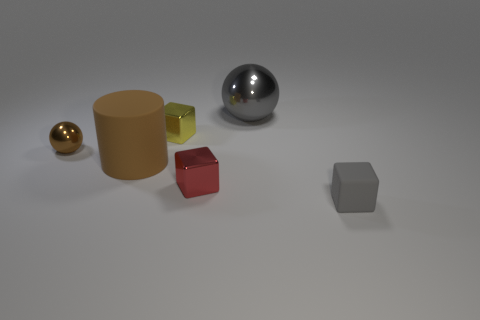Subtract all shiny blocks. How many blocks are left? 1 Subtract 1 cubes. How many cubes are left? 2 Add 2 big balls. How many objects exist? 8 Subtract all cylinders. How many objects are left? 5 Subtract all metal spheres. Subtract all purple spheres. How many objects are left? 4 Add 6 brown rubber objects. How many brown rubber objects are left? 7 Add 4 gray objects. How many gray objects exist? 6 Subtract 0 brown blocks. How many objects are left? 6 Subtract all gray cylinders. Subtract all green cubes. How many cylinders are left? 1 